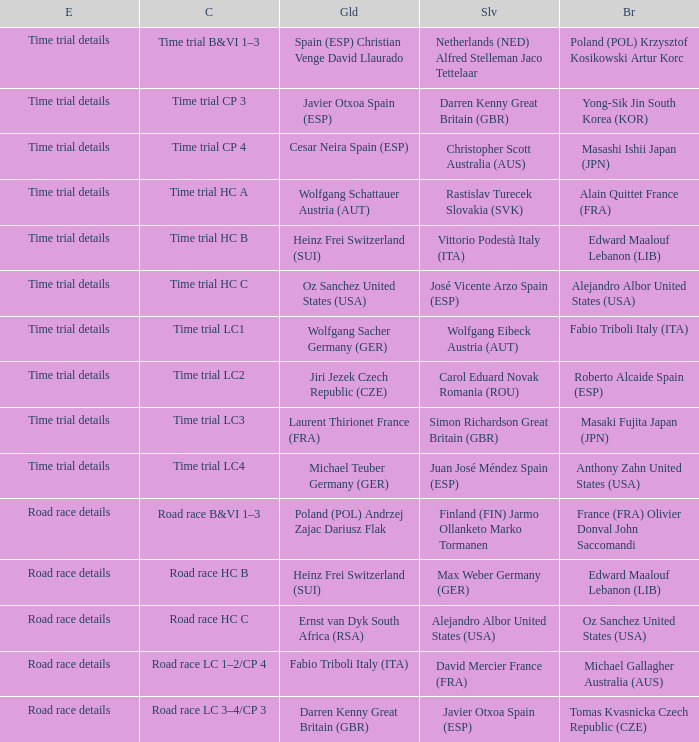Who received gold when silver is wolfgang eibeck austria (aut)? Wolfgang Sacher Germany (GER). 